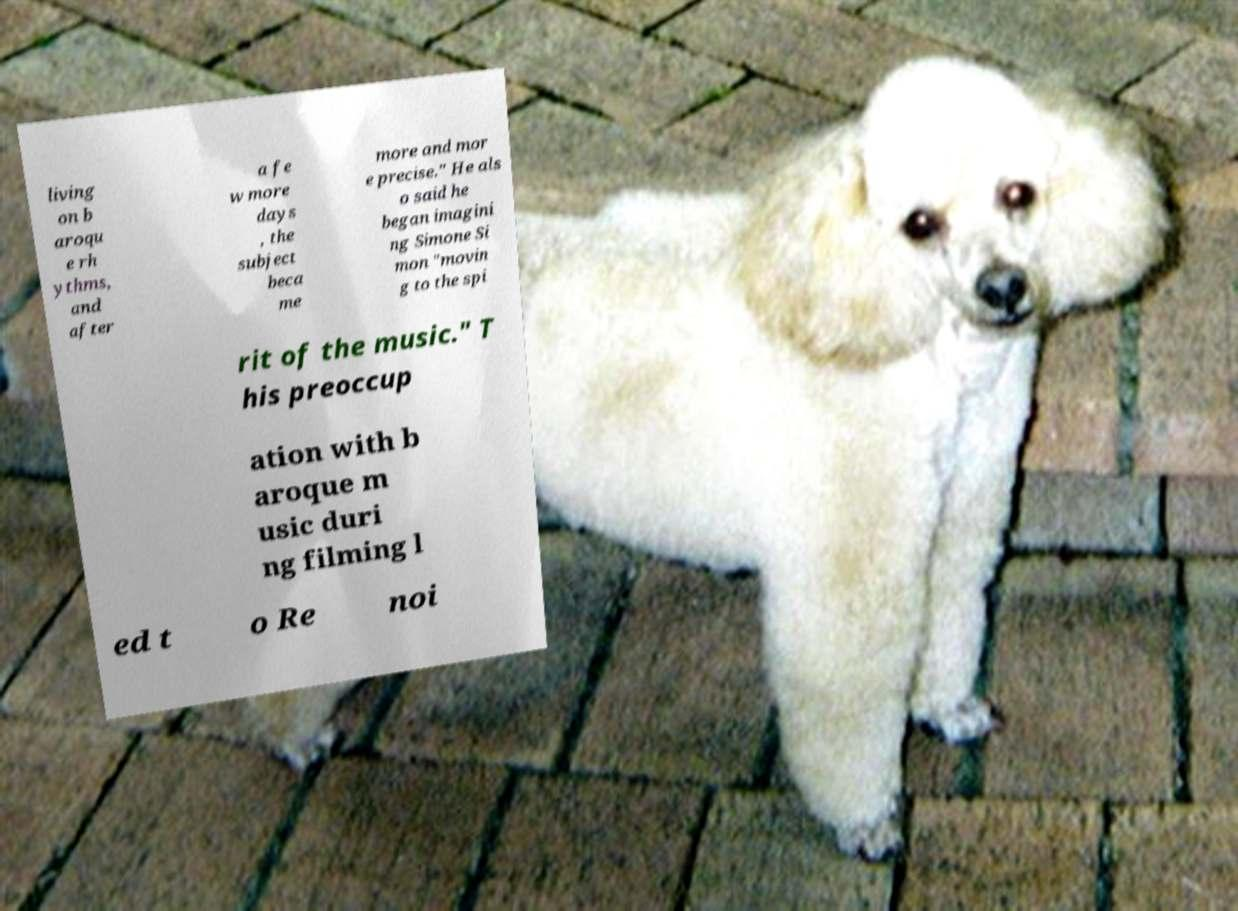I need the written content from this picture converted into text. Can you do that? living on b aroqu e rh ythms, and after a fe w more days , the subject beca me more and mor e precise." He als o said he began imagini ng Simone Si mon "movin g to the spi rit of the music." T his preoccup ation with b aroque m usic duri ng filming l ed t o Re noi 